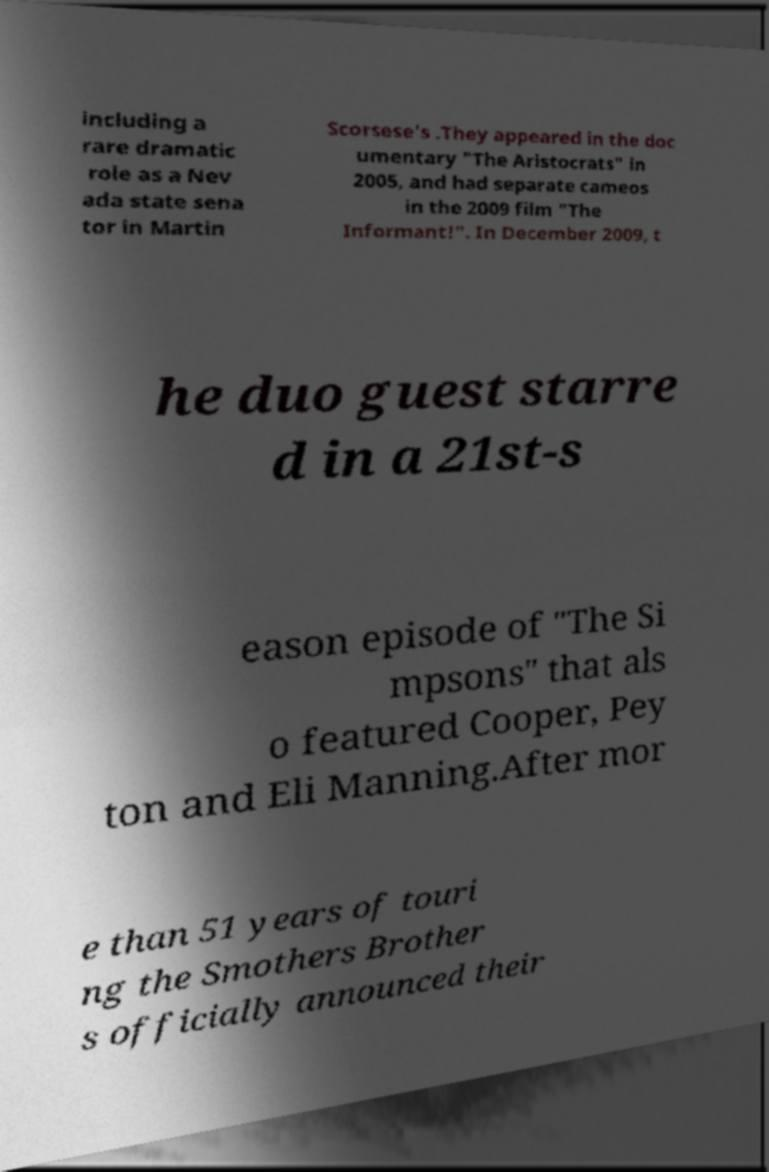I need the written content from this picture converted into text. Can you do that? including a rare dramatic role as a Nev ada state sena tor in Martin Scorsese's .They appeared in the doc umentary "The Aristocrats" in 2005, and had separate cameos in the 2009 film "The Informant!". In December 2009, t he duo guest starre d in a 21st-s eason episode of "The Si mpsons" that als o featured Cooper, Pey ton and Eli Manning.After mor e than 51 years of touri ng the Smothers Brother s officially announced their 